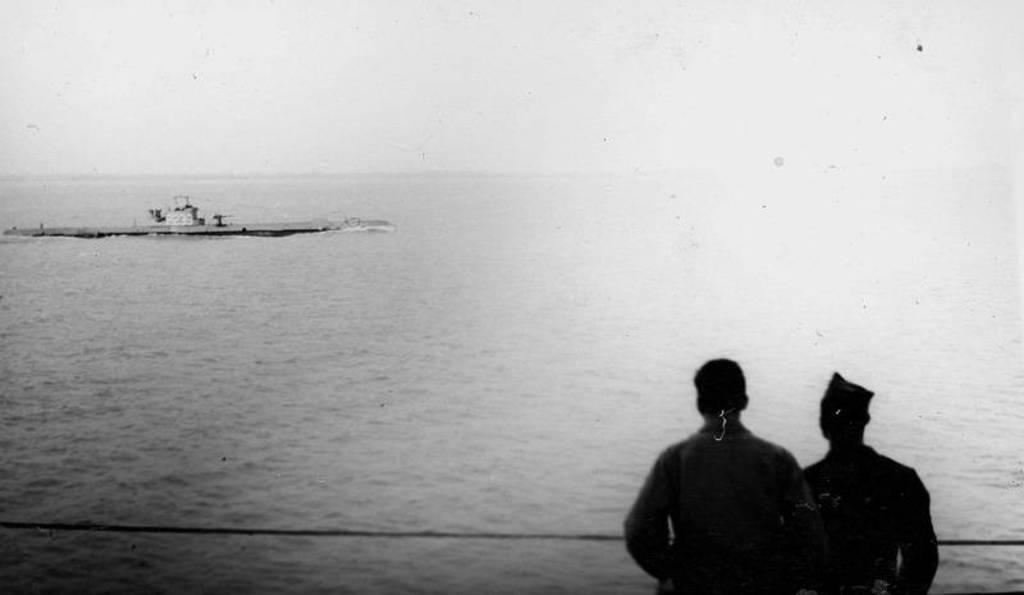Can you describe this image briefly? In this image there is the sky truncated towards the top of the image, there is the sea truncated, there is an object in the sea, there are two persons truncated towards the bottom of the image. 